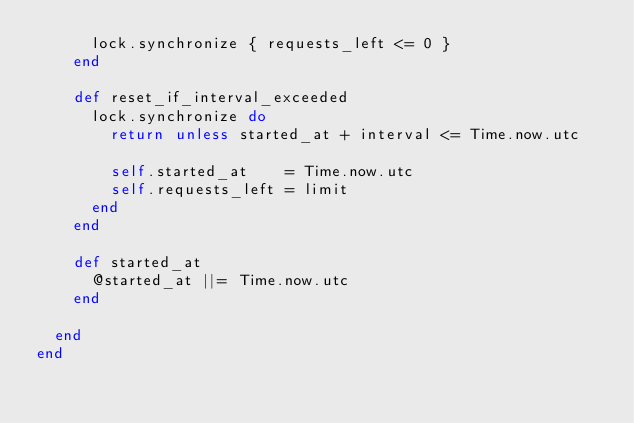Convert code to text. <code><loc_0><loc_0><loc_500><loc_500><_Ruby_>      lock.synchronize { requests_left <= 0 }
    end

    def reset_if_interval_exceeded
      lock.synchronize do
        return unless started_at + interval <= Time.now.utc

        self.started_at    = Time.now.utc
        self.requests_left = limit
      end
    end

    def started_at
      @started_at ||= Time.now.utc
    end

  end
end
</code> 